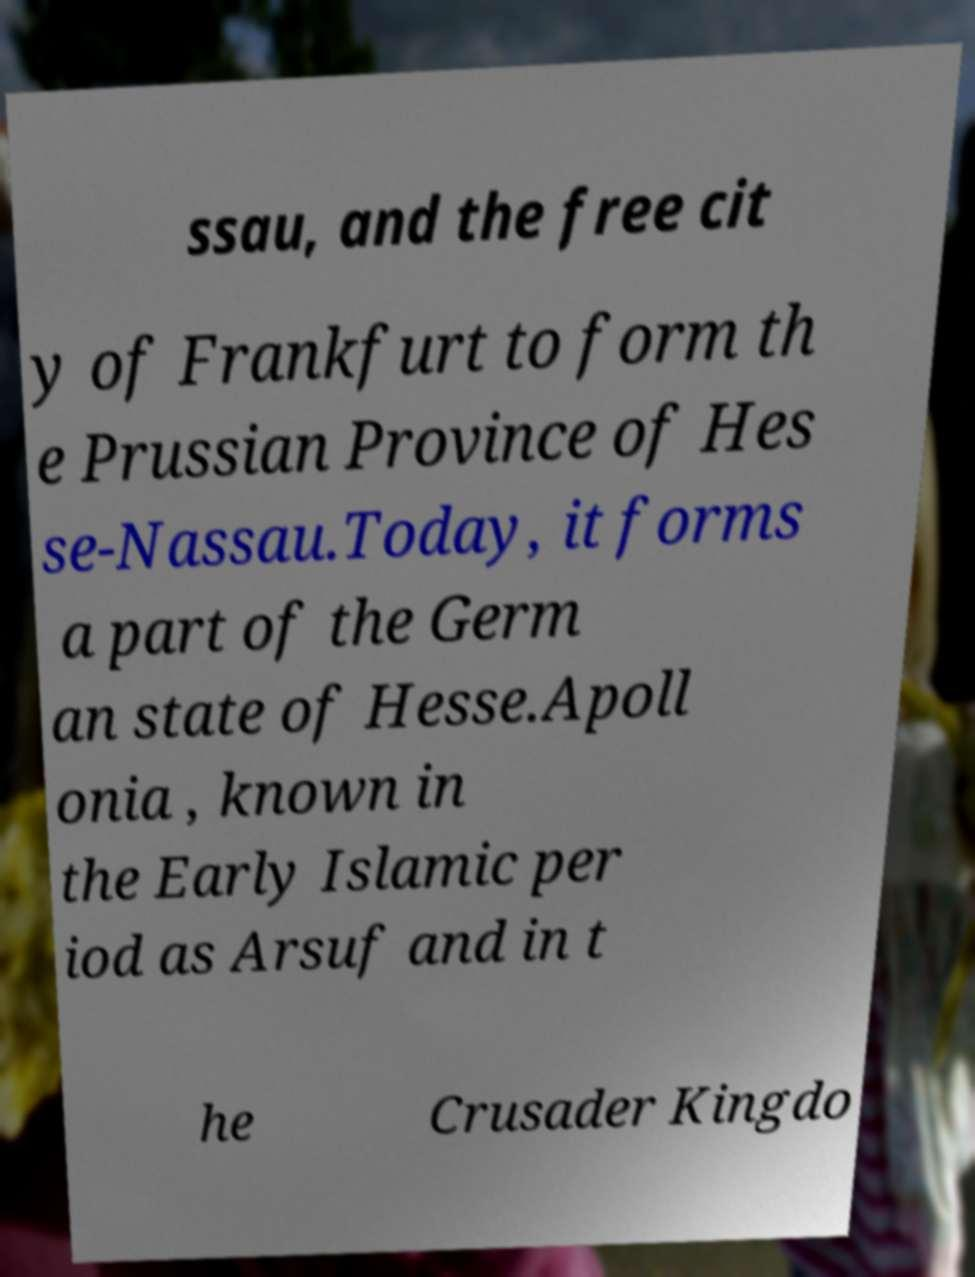I need the written content from this picture converted into text. Can you do that? ssau, and the free cit y of Frankfurt to form th e Prussian Province of Hes se-Nassau.Today, it forms a part of the Germ an state of Hesse.Apoll onia , known in the Early Islamic per iod as Arsuf and in t he Crusader Kingdo 